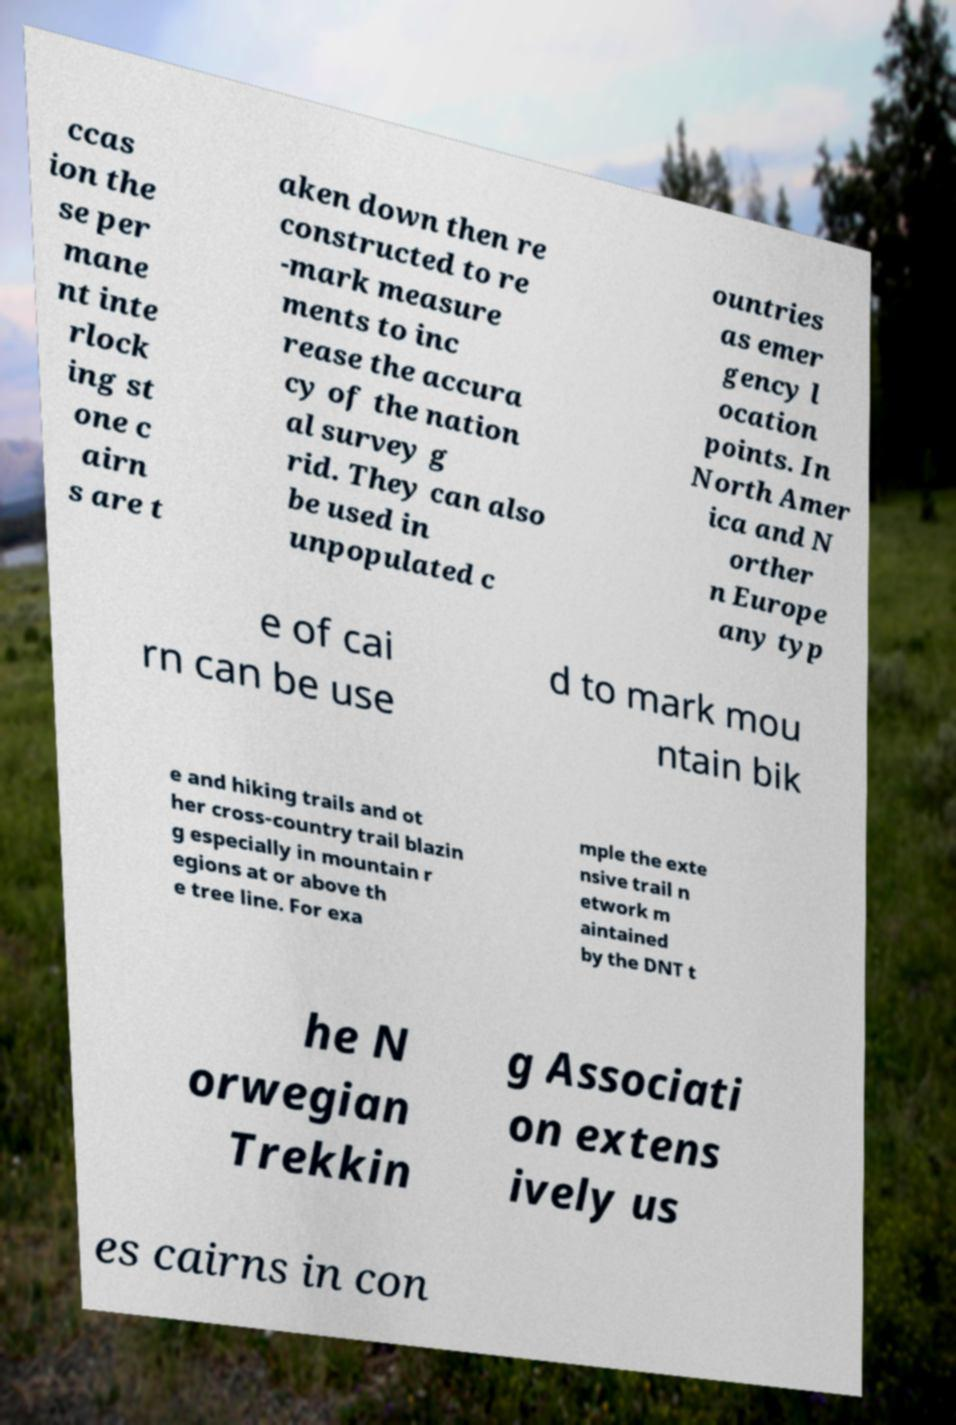Can you accurately transcribe the text from the provided image for me? ccas ion the se per mane nt inte rlock ing st one c airn s are t aken down then re constructed to re -mark measure ments to inc rease the accura cy of the nation al survey g rid. They can also be used in unpopulated c ountries as emer gency l ocation points. In North Amer ica and N orther n Europe any typ e of cai rn can be use d to mark mou ntain bik e and hiking trails and ot her cross-country trail blazin g especially in mountain r egions at or above th e tree line. For exa mple the exte nsive trail n etwork m aintained by the DNT t he N orwegian Trekkin g Associati on extens ively us es cairns in con 